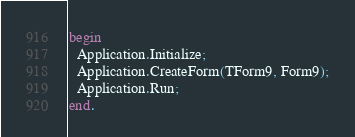<code> <loc_0><loc_0><loc_500><loc_500><_Pascal_>begin
  Application.Initialize;
  Application.CreateForm(TForm9, Form9);
  Application.Run;
end.
</code> 